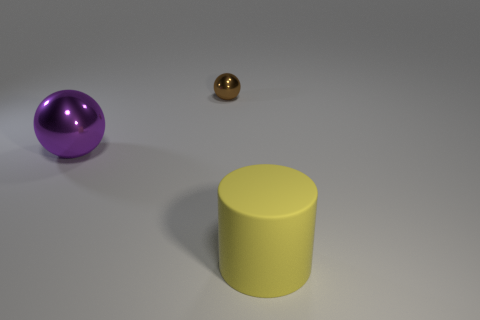Are there any other things that have the same material as the yellow cylinder?
Give a very brief answer. No. Is the number of big brown cylinders less than the number of purple things?
Provide a short and direct response. Yes. How big is the metallic object that is in front of the brown shiny thing?
Ensure brevity in your answer.  Large. The object that is both in front of the brown object and to the right of the big purple thing has what shape?
Provide a succinct answer. Cylinder. There is a brown metal object that is the same shape as the large purple shiny object; what size is it?
Provide a succinct answer. Small. How many big yellow objects are made of the same material as the large cylinder?
Provide a short and direct response. 0. There is a tiny metal object; is its color the same as the big object that is on the right side of the purple sphere?
Ensure brevity in your answer.  No. Is the number of things greater than the number of rubber spheres?
Provide a short and direct response. Yes. What color is the big metallic object?
Keep it short and to the point. Purple. Does the large object in front of the large sphere have the same color as the large shiny ball?
Give a very brief answer. No. 